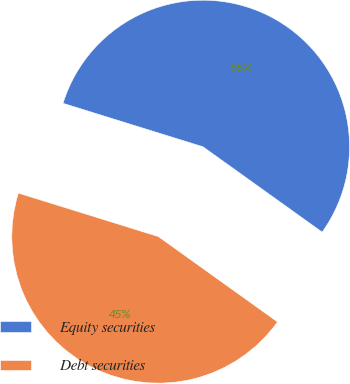Convert chart. <chart><loc_0><loc_0><loc_500><loc_500><pie_chart><fcel>Equity securities<fcel>Debt securities<nl><fcel>55.1%<fcel>44.9%<nl></chart> 